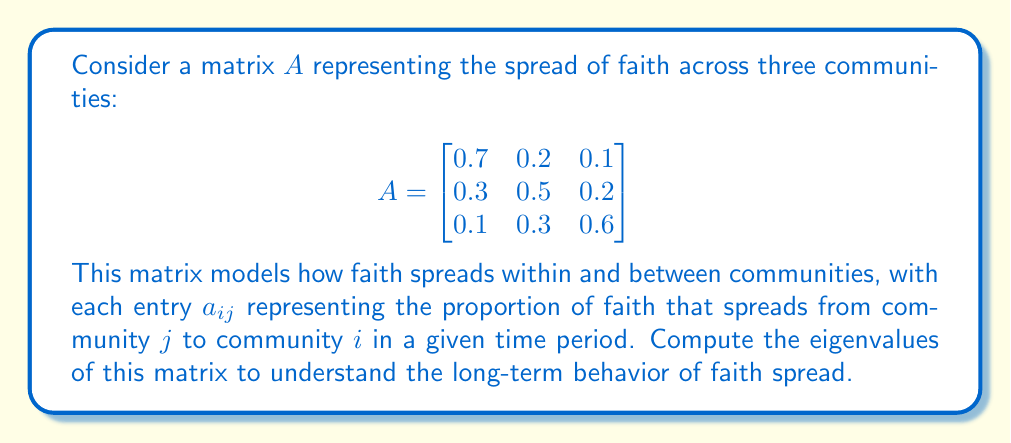Can you solve this math problem? To find the eigenvalues of matrix $A$, we need to solve the characteristic equation:

$$\det(A - \lambda I) = 0$$

where $\lambda$ represents the eigenvalues and $I$ is the 3x3 identity matrix.

Step 1: Set up the characteristic equation:

$$\begin{vmatrix}
0.7 - \lambda & 0.2 & 0.1 \\
0.3 & 0.5 - \lambda & 0.2 \\
0.1 & 0.3 & 0.6 - \lambda
\end{vmatrix} = 0$$

Step 2: Expand the determinant:

$$(0.7 - \lambda)[(0.5 - \lambda)(0.6 - \lambda) - 0.06] - 0.2[0.3(0.6 - \lambda) - 0.02] + 0.1[0.3(0.5 - \lambda) - 0.06] = 0$$

Step 3: Simplify:

$$(0.7 - \lambda)(0.3 - \lambda - \lambda^2) - 0.2(0.18 - 0.3\lambda) + 0.1(0.15 - 0.3\lambda) = 0$$

Step 4: Expand and collect terms:

$$-\lambda^3 + 1.8\lambda^2 - 0.89\lambda + 0.12 = 0$$

Step 5: Solve the cubic equation. This can be done using the cubic formula or numerical methods. The eigenvalues are approximately:

$\lambda_1 \approx 1$
$\lambda_2 \approx 0.5$
$\lambda_3 \approx 0.3$

The largest eigenvalue ($\lambda_1 \approx 1$) represents the long-term growth rate of faith in the system. Since it's close to 1, it suggests a stable spread of faith across the communities over time.
Answer: $\lambda_1 \approx 1$, $\lambda_2 \approx 0.5$, $\lambda_3 \approx 0.3$ 